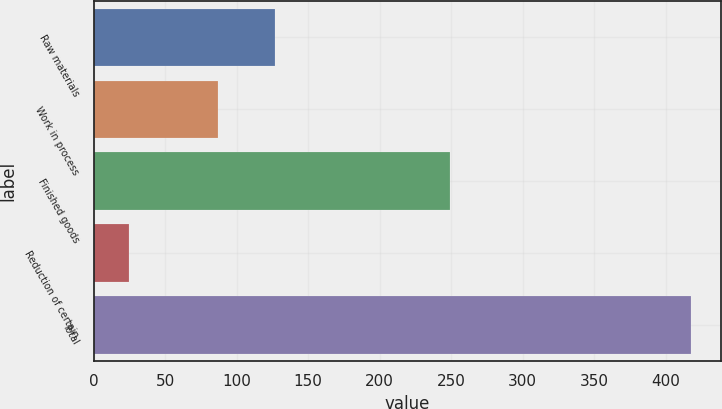Convert chart. <chart><loc_0><loc_0><loc_500><loc_500><bar_chart><fcel>Raw materials<fcel>Work in process<fcel>Finished goods<fcel>Reduction of certain<fcel>Total<nl><fcel>126.5<fcel>87.2<fcel>249.5<fcel>24.9<fcel>417.9<nl></chart> 